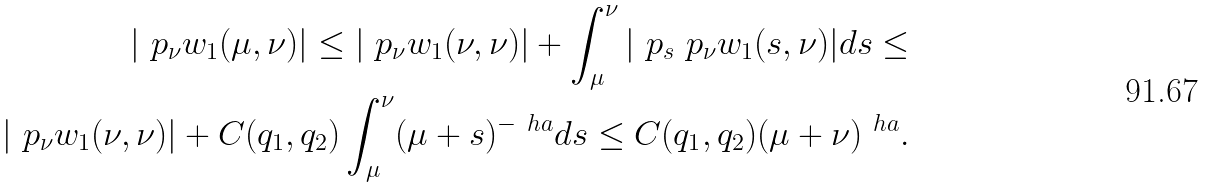<formula> <loc_0><loc_0><loc_500><loc_500>| \ p _ { \nu } w _ { 1 } ( \mu , \nu ) | \leq | \ p _ { \nu } w _ { 1 } ( \nu , \nu ) | + \int _ { \mu } ^ { \nu } | \ p _ { s } \ p _ { \nu } w _ { 1 } ( s , \nu ) | d s \leq \\ | \ p _ { \nu } w _ { 1 } ( \nu , \nu ) | + C ( q _ { 1 } , q _ { 2 } ) \int _ { \mu } ^ { \nu } ( \mu + s ) ^ { - \ h a } d s \leq C ( q _ { 1 } , q _ { 2 } ) ( \mu + \nu ) ^ { \ h a } .</formula> 